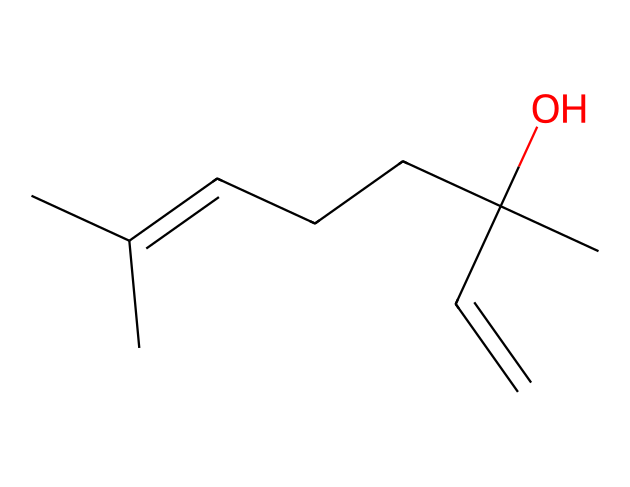What is the molecular formula of linalool? To determine the molecular formula, count the number of carbon (C), hydrogen (H), and oxygen (O) atoms in the SMILES representation. In the provided SMILES, there are 10 carbon atoms, 18 hydrogen atoms, and 1 oxygen atom. Therefore, the molecular formula is C10H18O.
Answer: C10H18O How many double bonds are present in the structure of linalool? In the SMILES representation, the presence of '=' indicates double bonds. By analyzing the structure, we can see that there are two occurrences of double bonds; one between the carbon and its neighbor and another between the two carbon atoms. Thus, there are two double bonds.
Answer: 2 What functional group is represented in the linalool structure? By examining the structure, we can identify the hydroxyl (-OH) group attached to a carbon atom, which indicates that linalool contains an alcohol functional group.
Answer: alcohol Is linalool a saturated or unsaturated compound? To determine if the compound is saturated or unsaturated, we look at the number of double bonds and the presence of the alcohol group. The presence of double bonds indicates that linalool is not fully saturated with hydrogen; therefore, it is an unsaturated compound.
Answer: unsaturated What type of terpene is linalool based on its structure? Linalool is classified as an acyclic terpene due to its linear structure without forming a closed ring. The presence of multiple carbon chains also supports this classification.
Answer: acyclic 